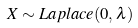Convert formula to latex. <formula><loc_0><loc_0><loc_500><loc_500>X \sim { L a p l a c e } ( 0 , \lambda )</formula> 